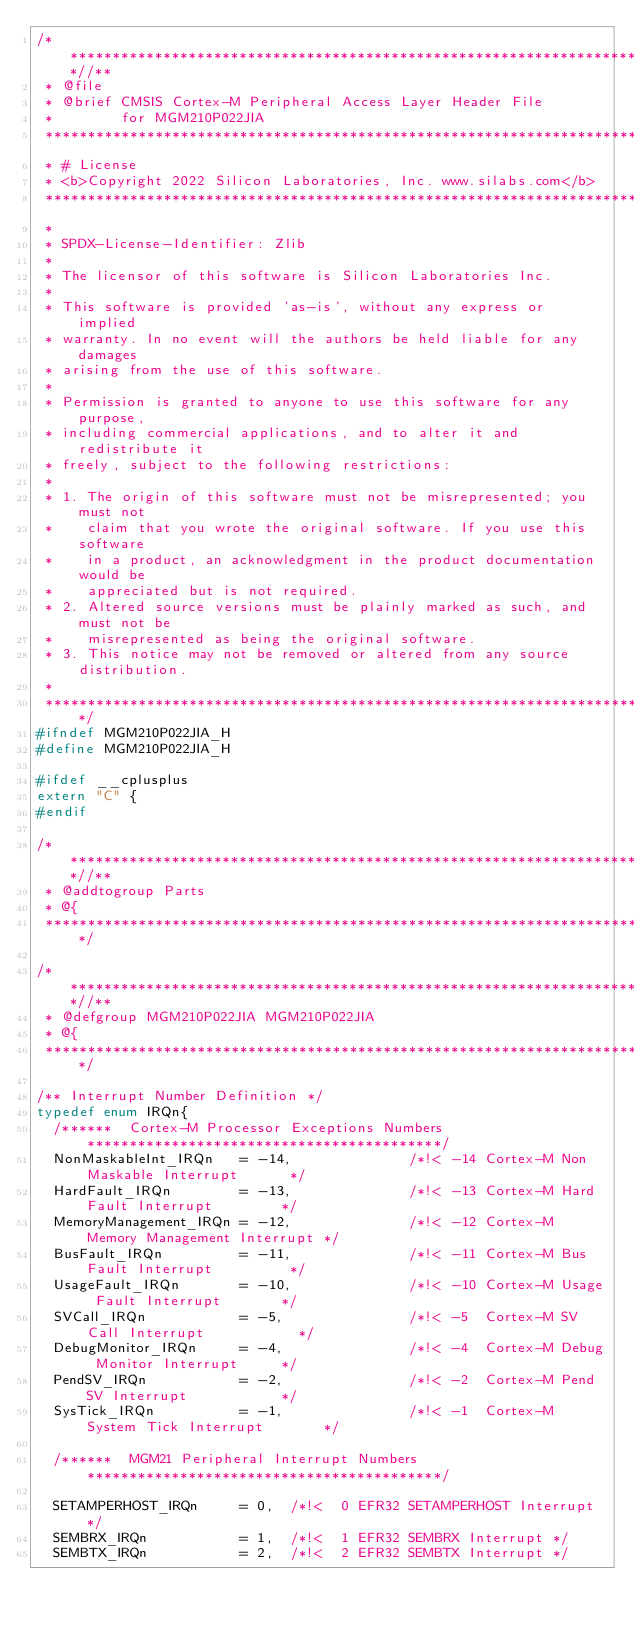<code> <loc_0><loc_0><loc_500><loc_500><_C_>/**************************************************************************//**
 * @file
 * @brief CMSIS Cortex-M Peripheral Access Layer Header File
 *        for MGM210P022JIA
 ******************************************************************************
 * # License
 * <b>Copyright 2022 Silicon Laboratories, Inc. www.silabs.com</b>
 ******************************************************************************
 *
 * SPDX-License-Identifier: Zlib
 *
 * The licensor of this software is Silicon Laboratories Inc.
 *
 * This software is provided 'as-is', without any express or implied
 * warranty. In no event will the authors be held liable for any damages
 * arising from the use of this software.
 *
 * Permission is granted to anyone to use this software for any purpose,
 * including commercial applications, and to alter it and redistribute it
 * freely, subject to the following restrictions:
 *
 * 1. The origin of this software must not be misrepresented; you must not
 *    claim that you wrote the original software. If you use this software
 *    in a product, an acknowledgment in the product documentation would be
 *    appreciated but is not required.
 * 2. Altered source versions must be plainly marked as such, and must not be
 *    misrepresented as being the original software.
 * 3. This notice may not be removed or altered from any source distribution.
 *
 *****************************************************************************/
#ifndef MGM210P022JIA_H
#define MGM210P022JIA_H

#ifdef __cplusplus
extern "C" {
#endif

/**************************************************************************//**
 * @addtogroup Parts
 * @{
 *****************************************************************************/

/**************************************************************************//**
 * @defgroup MGM210P022JIA MGM210P022JIA
 * @{
 *****************************************************************************/

/** Interrupt Number Definition */
typedef enum IRQn{
  /******  Cortex-M Processor Exceptions Numbers ******************************************/
  NonMaskableInt_IRQn   = -14,              /*!< -14 Cortex-M Non Maskable Interrupt      */
  HardFault_IRQn        = -13,              /*!< -13 Cortex-M Hard Fault Interrupt        */
  MemoryManagement_IRQn = -12,              /*!< -12 Cortex-M Memory Management Interrupt */
  BusFault_IRQn         = -11,              /*!< -11 Cortex-M Bus Fault Interrupt         */
  UsageFault_IRQn       = -10,              /*!< -10 Cortex-M Usage Fault Interrupt       */
  SVCall_IRQn           = -5,               /*!< -5  Cortex-M SV Call Interrupt           */
  DebugMonitor_IRQn     = -4,               /*!< -4  Cortex-M Debug Monitor Interrupt     */
  PendSV_IRQn           = -2,               /*!< -2  Cortex-M Pend SV Interrupt           */
  SysTick_IRQn          = -1,               /*!< -1  Cortex-M System Tick Interrupt       */

  /******  MGM21 Peripheral Interrupt Numbers ******************************************/

  SETAMPERHOST_IRQn     = 0,  /*!<  0 EFR32 SETAMPERHOST Interrupt */
  SEMBRX_IRQn           = 1,  /*!<  1 EFR32 SEMBRX Interrupt */
  SEMBTX_IRQn           = 2,  /*!<  2 EFR32 SEMBTX Interrupt */</code> 